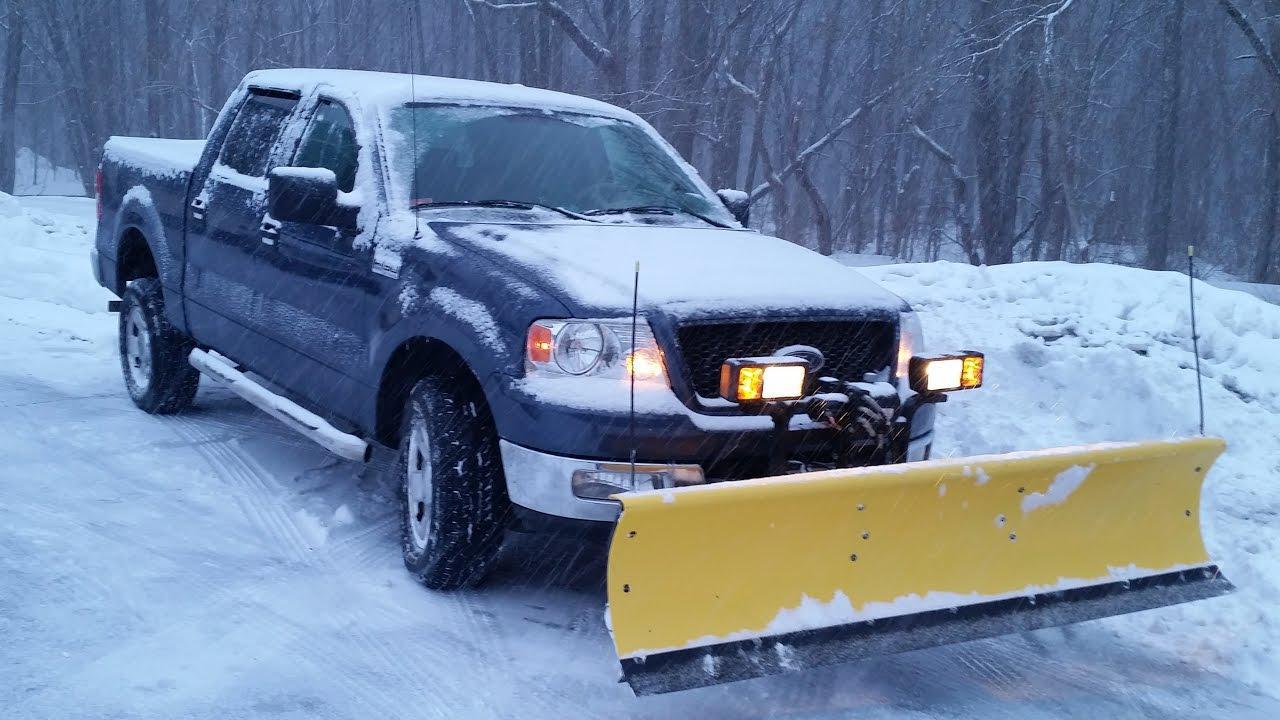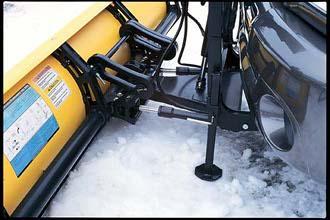The first image is the image on the left, the second image is the image on the right. For the images shown, is this caption "Each image shows one gray truck equipped with a bright yellow snow plow and parked on snowy ground." true? Answer yes or no. No. The first image is the image on the left, the second image is the image on the right. Evaluate the accuracy of this statement regarding the images: "A blue vehicle is pushing a yellow plow in the image on the left.". Is it true? Answer yes or no. Yes. 